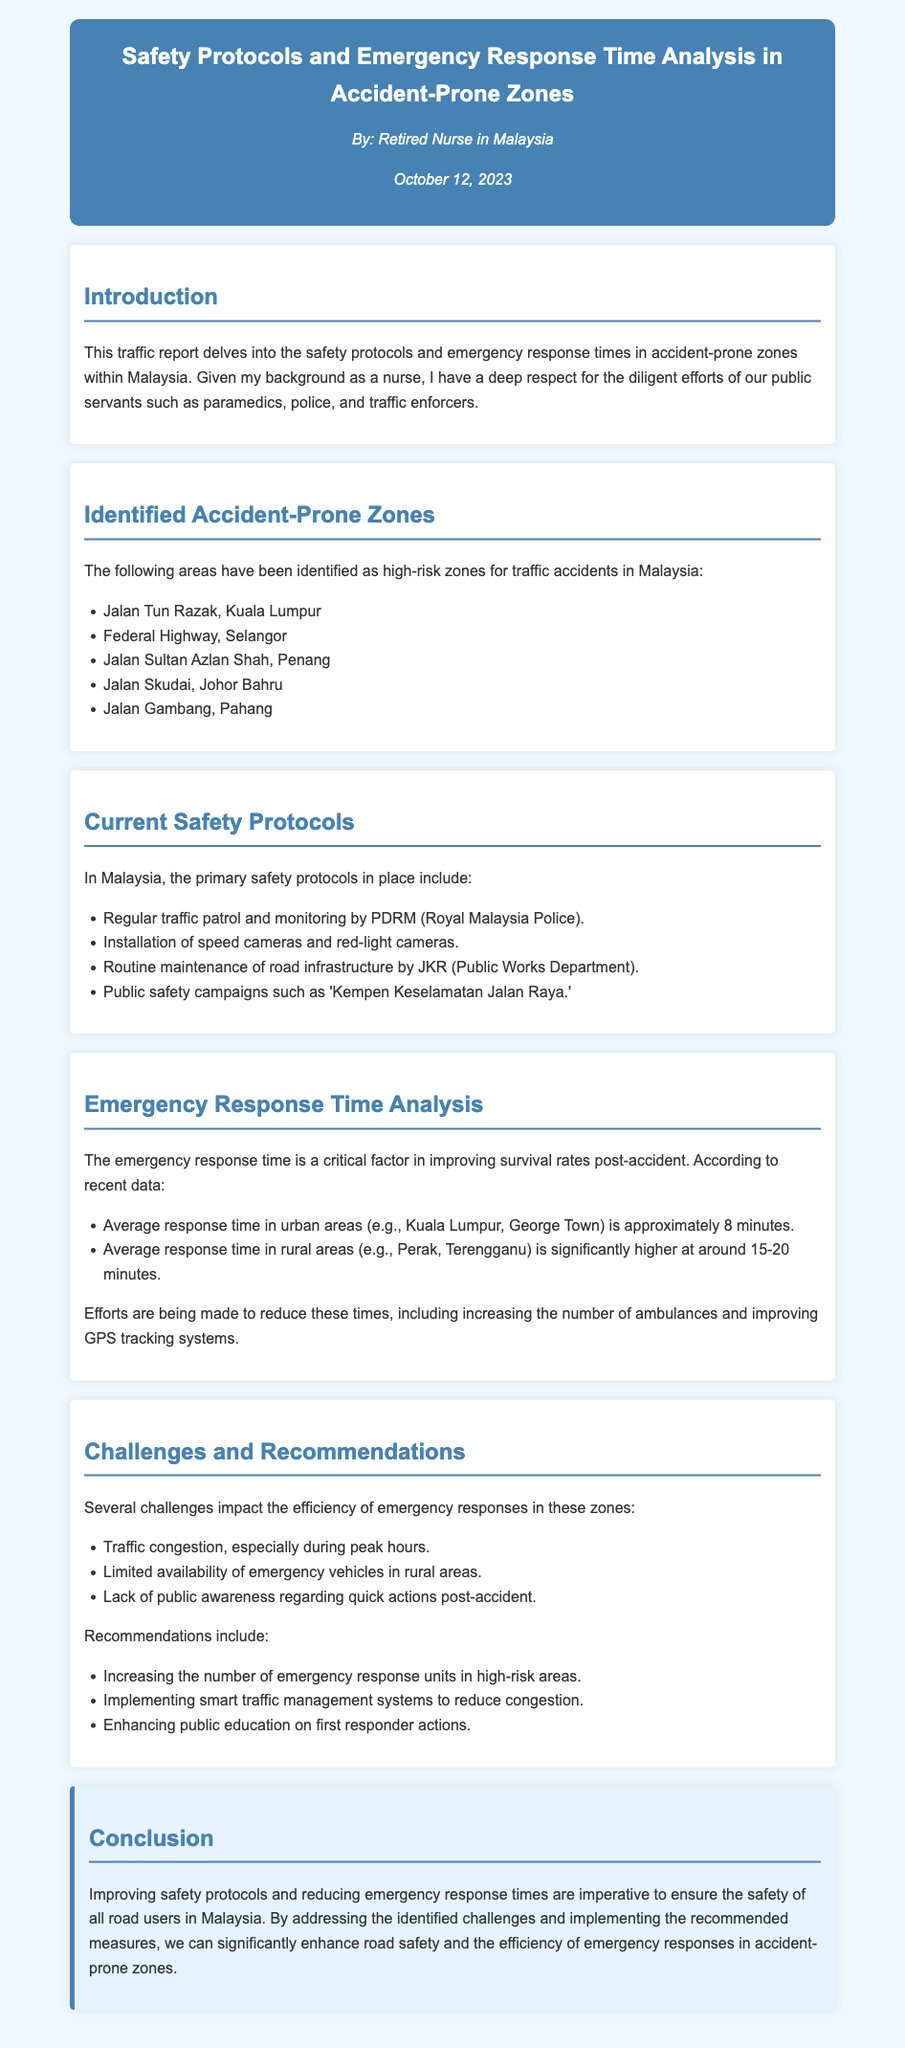What are the identified accident-prone zones? The document lists five specific areas identified as high-risk zones for traffic accidents in Malaysia.
Answer: Jalan Tun Razak, Federal Highway, Jalan Sultan Azlan Shah, Jalan Skudai, Jalan Gambang What is the average response time in urban areas? The document provides average response times based on geographic regions, noting urban areas have a specific time mentioned.
Answer: 8 minutes What safety protocol involves public information dissemination? The document discusses various safety protocols and highlights one which refers to public campaigns focused on road safety.
Answer: Public safety campaigns What is a major challenge affecting emergency response efficiency? The document specifically lists several challenges, and one of them pertains to traffic conditions during certain times.
Answer: Traffic congestion What additional measure is recommended to improve emergency response? The document offers recommendations for enhancing emergency services and mentions an increase in the number of a specific type of service unit.
Answer: Emergency response units How long is the average response time in rural areas? The document specifies the average response times based on regions and assigns a time frame to rural areas.
Answer: 15-20 minutes 